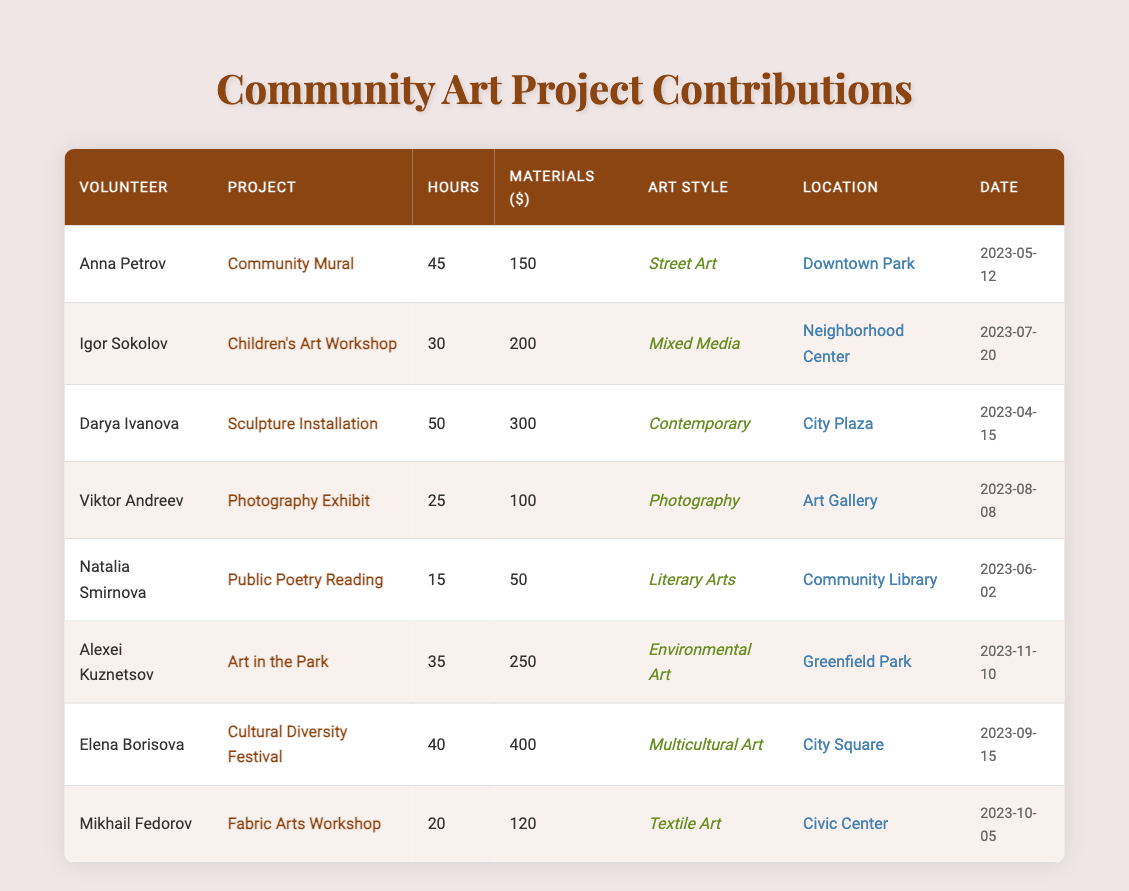What is the total number of hours contributed by all volunteers? To find the total hours, sum the "Hours Contributed" for each volunteer: 45 + 30 + 50 + 25 + 15 + 35 + 40 + 20 = 290.
Answer: 290 Which project had the highest materials donated? The project with the highest materials donated is the "Cultural Diversity Festival" with $400.
Answer: Cultural Diversity Festival How many volunteers contributed to community art projects in total? Counting the unique volunteers listed in the table, there are 8 distinct individuals contributing.
Answer: 8 Which art style received the least amount of hours contributed? The "Public Poetry Reading" with 15 hours is the least among the listed art styles.
Answer: Literary Arts What is the average number of hours contributed per project? There are 8 projects, and the total hours contributed is 290; dividing 290 by 8 gives 36.25.
Answer: 36.25 Did any volunteer donate more materials than they contributed hours? Yes, both Anna Petrov and Elena Borisova donated more materials ($150 and $400, respectively) than their contributed hours (45 and 40 hours).
Answer: Yes How many more materials were donated to the "Sculpture Installation" project compared to the "Photography Exhibit"? The "Sculpture Installation" had $300 materials, while the "Photography Exhibit" had $100, resulting in a difference of $200.
Answer: $200 What percentage of total hours contributed were for the "Children's Art Workshop"? The contribution for the "Children's Art Workshop" is 30 hours; the percentage is (30/290) * 100 = 10.34%.
Answer: 10.34% Which two projects had the same number of volunteers contributing? The "Photography Exhibit" and "Fabric Arts Workshop" each had contributions from just one volunteer each.
Answer: Photography Exhibit & Fabric Arts Workshop What is the date of the project with the maximum hours contributed? The "Sculpture Installation" project had the maximum hours at 50, and its date is 2023-04-15.
Answer: 2023-04-15 